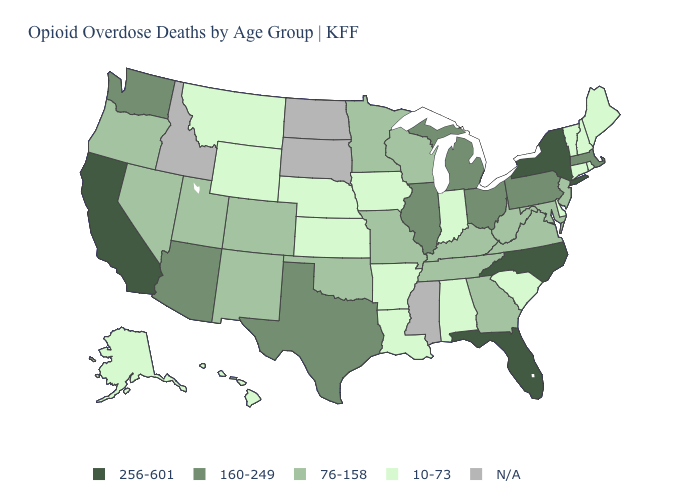Which states have the highest value in the USA?
Quick response, please. California, Florida, New York, North Carolina. What is the value of Ohio?
Concise answer only. 160-249. What is the lowest value in states that border New Jersey?
Write a very short answer. 10-73. Which states have the lowest value in the USA?
Answer briefly. Alabama, Alaska, Arkansas, Connecticut, Delaware, Hawaii, Indiana, Iowa, Kansas, Louisiana, Maine, Montana, Nebraska, New Hampshire, Rhode Island, South Carolina, Vermont, Wyoming. Which states have the highest value in the USA?
Be succinct. California, Florida, New York, North Carolina. Among the states that border New Mexico , does Arizona have the highest value?
Concise answer only. Yes. What is the lowest value in the USA?
Keep it brief. 10-73. Does Indiana have the lowest value in the USA?
Keep it brief. Yes. What is the value of Arkansas?
Answer briefly. 10-73. Which states have the lowest value in the USA?
Quick response, please. Alabama, Alaska, Arkansas, Connecticut, Delaware, Hawaii, Indiana, Iowa, Kansas, Louisiana, Maine, Montana, Nebraska, New Hampshire, Rhode Island, South Carolina, Vermont, Wyoming. What is the highest value in states that border Mississippi?
Short answer required. 76-158. Name the states that have a value in the range 76-158?
Write a very short answer. Colorado, Georgia, Kentucky, Maryland, Minnesota, Missouri, Nevada, New Jersey, New Mexico, Oklahoma, Oregon, Tennessee, Utah, Virginia, West Virginia, Wisconsin. What is the lowest value in states that border Alabama?
Answer briefly. 76-158. 